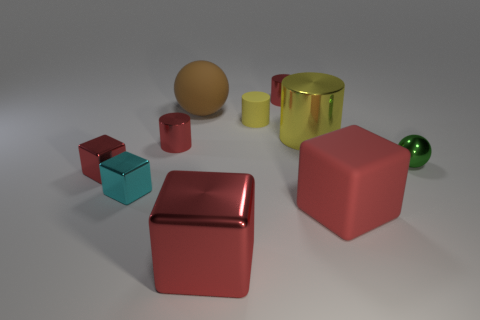Are there any brown balls that have the same material as the large yellow object?
Ensure brevity in your answer.  No. How many things are yellow cylinders left of the rubber block or tiny metal objects that are in front of the small green object?
Offer a terse response. 4. There is a metal object that is in front of the small cyan shiny thing; is its color the same as the rubber block?
Keep it short and to the point. Yes. How many other objects are there of the same color as the big metallic cube?
Offer a terse response. 4. What is the material of the small yellow cylinder?
Keep it short and to the point. Rubber. There is a block that is left of the cyan cube; is it the same size as the small ball?
Give a very brief answer. Yes. There is a cyan metal object that is the same shape as the red rubber object; what is its size?
Offer a terse response. Small. Are there an equal number of brown things in front of the small red cube and green things behind the tiny yellow matte thing?
Make the answer very short. Yes. There is a rubber thing in front of the tiny green metal object; what size is it?
Ensure brevity in your answer.  Large. Do the matte sphere and the big metallic block have the same color?
Give a very brief answer. No. 